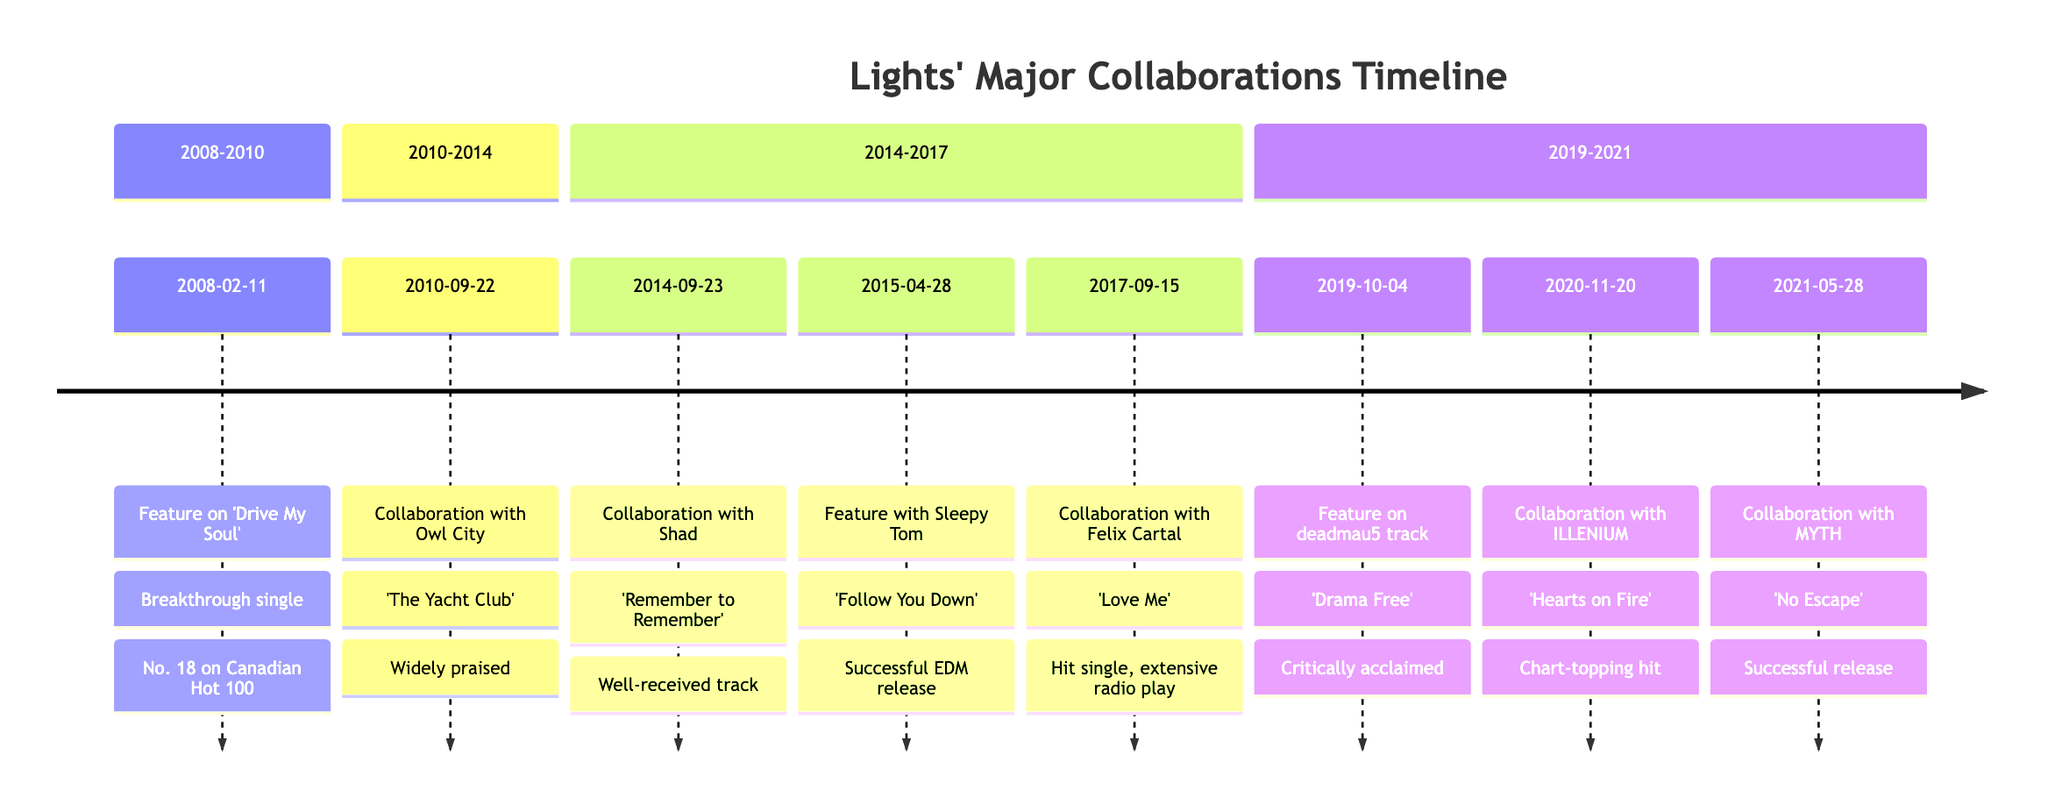What date was "Drive My Soul" released? The timeline shows that "Drive My Soul," featuring Lights, was released on February 11, 2008.
Answer: February 11, 2008 How many collaborations did Lights have between 2010 and 2014? Counting the entries in the section for 2010-2014, there are two collaborations: with Owl City and with Shad.
Answer: 2 What was the outcome of the collaboration with ILLENIUM? The timeline states that the outcome of the collaboration with ILLENIUM on "Hearts on Fire" was a chart-topping hit.
Answer: Chart-topping hit Which collaboration highlighted Lights' versatility? The entry for the collaboration with Shad on "Remember to Remember" specifically mentions that it highlighted Lights' versatility.
Answer: Collaboration with Shad What is the title of the track released with Felix Cartal? The timeline indicates that the track released with Felix Cartal is titled "Love Me."
Answer: Love Me In which year did Lights collaborate with MYTH? The timeline specifies that the collaboration with MYTH occurred in 2021, specifically on May 28.
Answer: 2021 What is the earliest collaboration indicated in the timeline? The earliest entry in the timeline is dated February 11, 2008, for the feature on "Drive My Soul."
Answer: February 11, 2008 What genre did the feature with Sleepy Tom expand Lights' reach into? The outcome for the feature on "Follow You Down" with Sleepy Tom indicates it expanded Lights' reach into the EDM genre.
Answer: EDM genre How was the collaboration with Owl City received? The timeline states that the collaboration with Owl City on "The Yacht Club" was widely praised.
Answer: Widely praised 